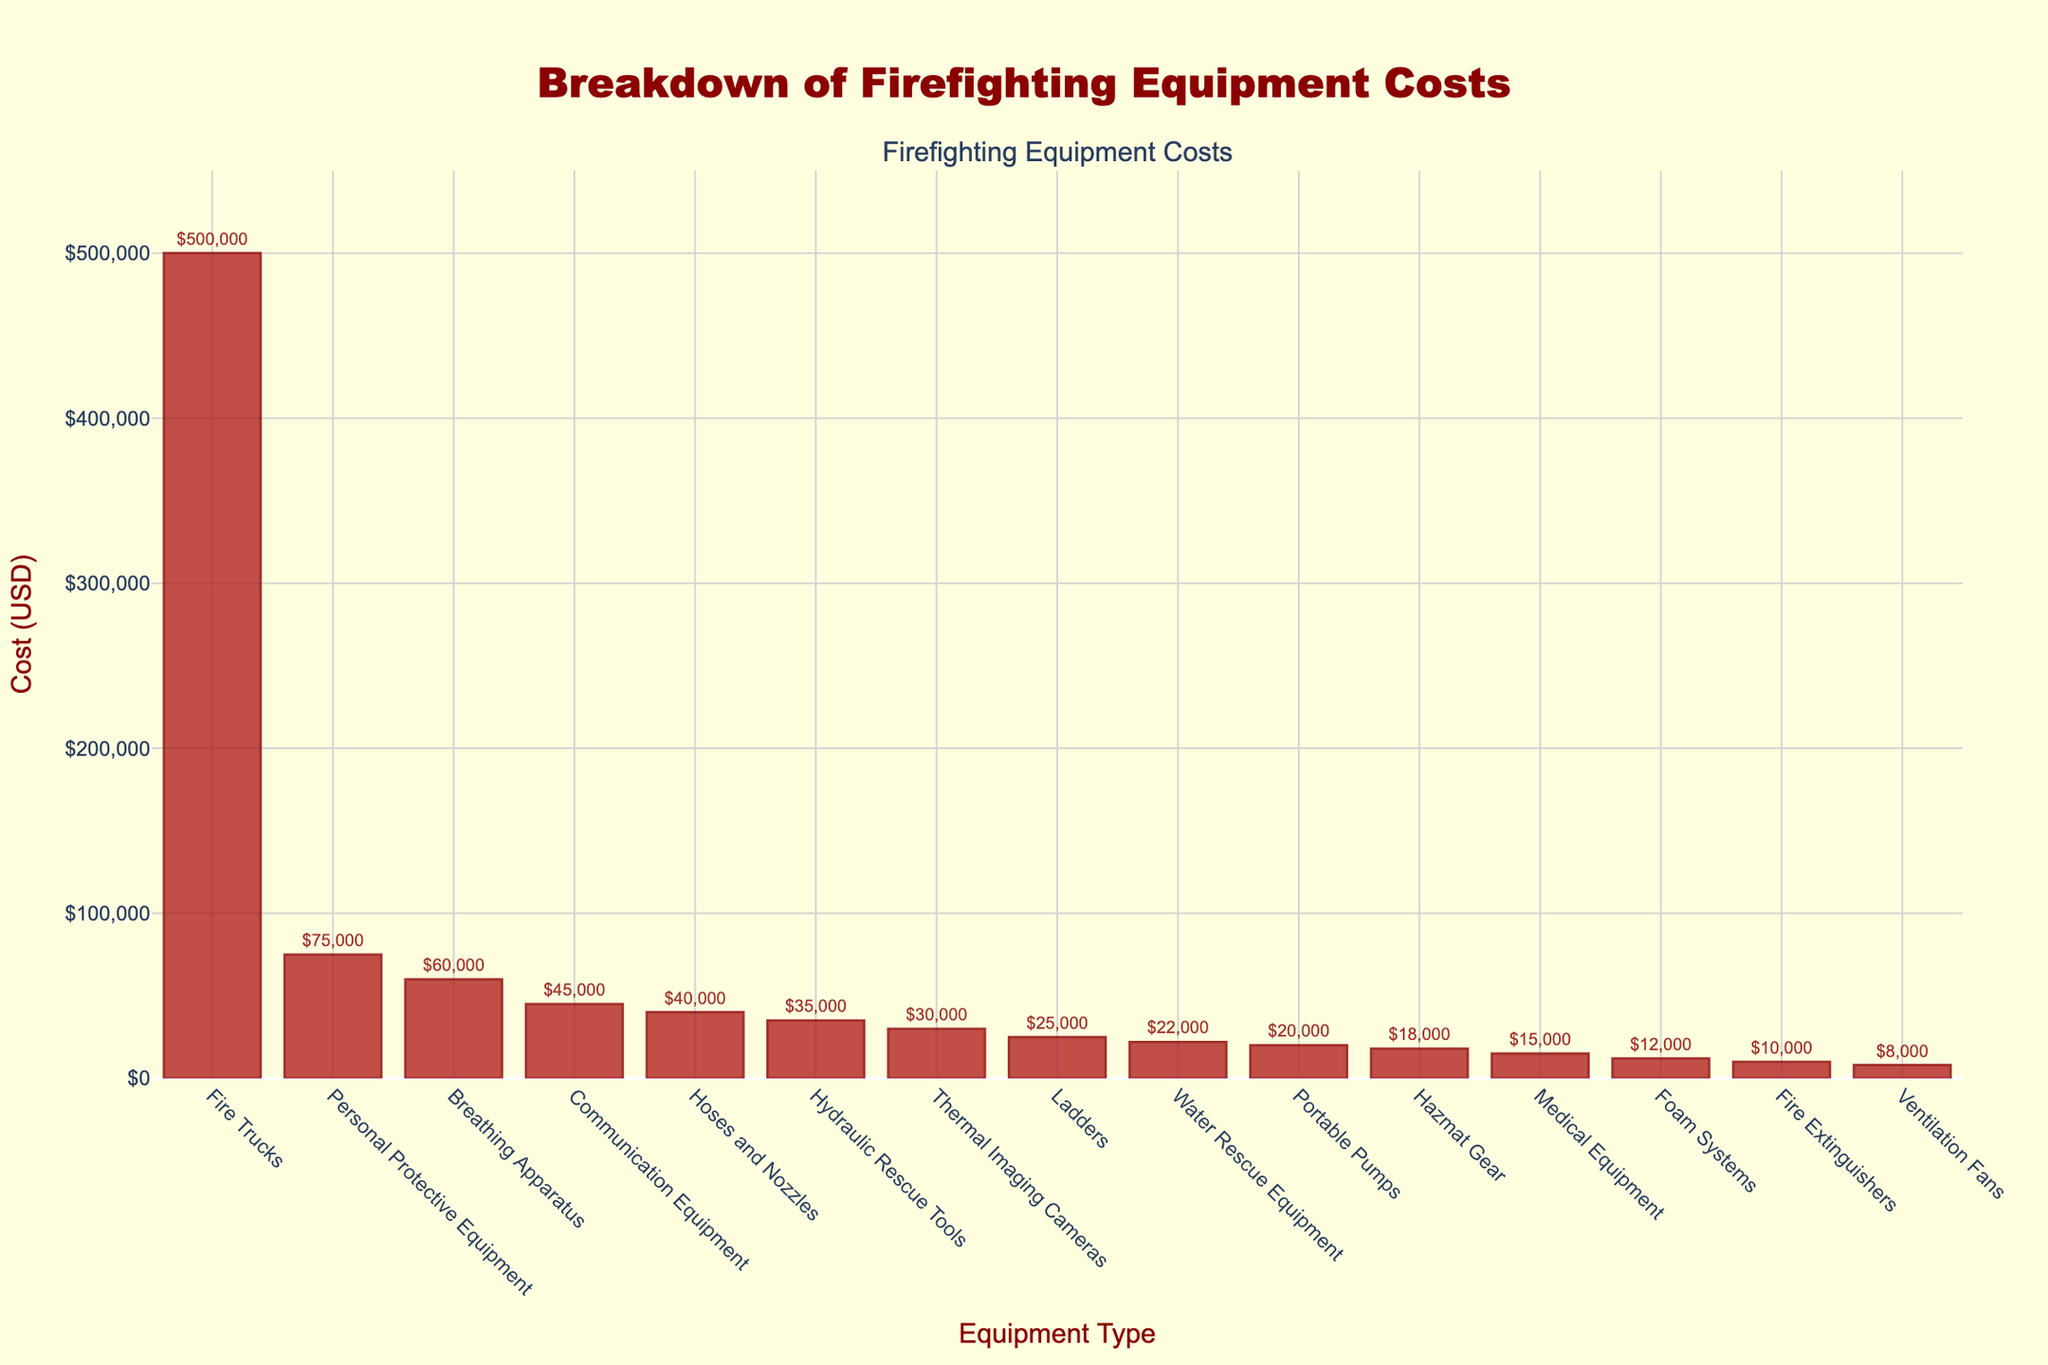What is the total cost of Fire Trucks and Hydraulic Rescue Tools? To find the total cost, sum the cost of Fire Trucks and Hydraulic Rescue Tools. Fire Trucks cost $500,000, and Hydraulic Rescue Tools cost $35,000. So, the total cost is $500,000 + $35,000 = $535,000.
Answer: $535,000 Which equipment has the second highest cost? By observing the height of the bars, Fire Trucks have the highest cost. The next highest bar is Personal Protective Equipment.
Answer: Personal Protective Equipment How much more does Personal Protective Equipment cost compared to Hoses and Nozzles? Personal Protective Equipment costs $75,000, and Hoses and Nozzles cost $40,000. The difference is $75,000 - $40,000 = $35,000.
Answer: $35,000 What is the range of costs shown in the bar chart? The range is calculated by finding the difference between the highest and lowest cost. The highest cost is for Fire Trucks ($500,000), and the lowest cost is for Ventilation Fans ($8,000). So, the range is $500,000 - $8,000 = $492,000.
Answer: $492,000 Which equipment costs the least and how much is it? By observing the shortest bar, Ventilation Fans cost the least at $8,000.
Answer: Ventilation Fans, $8,000 What is the combined cost of all equipment that costs less than $20,000? The equipment costing less than $20,000 includes Portable Pumps ($20,000), Fire Extinguishers ($10,000), Ventilation Fans ($8,000), Foam Systems ($12,000), Hazmat Gear ($18,000), and Water Rescue Equipment ($22,000). Adding these gives $20,000 + $10,000 + $8,000 + $12,000 + $18,000 = $68,000.
Answer: $68,000 How many equipment types have costs greater than $50,000? Counting the bars exceeding $50,000, we have Fire Trucks, Personal Protective Equipment, Breathing Apparatus, and Communication Equipment.
Answer: 4 What is the difference in cost between the highest and the second highest cost equipment? The highest cost equipment is Fire Trucks at $500,000, and the second highest is Personal Protective Equipment at $75,000. The difference is $500,000 - $75,000 = $425,000.
Answer: $425,000 What percentage of the total cost does the Breathing Apparatus have? First, find the cost of Breathing Apparatus ($60,000), then sum up all costs ($500,000 + $75,000 + $40,000 + $60,000 + $35,000 + $25,000 + $30,000 + $20,000 + $10,000 + $45,000 + $15,000 + $8,000 + $12,000 + $18,000 + $22,000 = $915,000). The percentage is ($60,000 / $915,000) * 100 ≈ 6.56%.
Answer: 6.56% Which costs more, Breathing Apparatus and Thermal Imaging Cameras combined or Hoses and Nozzles and Communication Equipment combined? Breathing Apparatus and Thermal Imaging Cameras: $60,000 + $30,000 = $90,000. Hoses and Nozzles and Communication Equipment: $40,000 + $45,000 = $85,000. So, the former (Breathing Apparatus and Thermal Imaging Cameras) costs more.
Answer: Breathing Apparatus and Thermal Imaging Cameras 